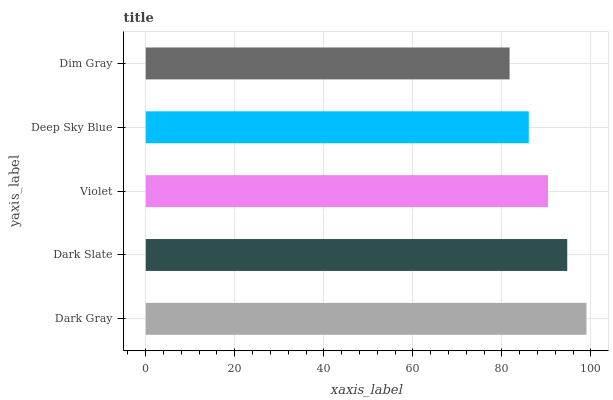Is Dim Gray the minimum?
Answer yes or no. Yes. Is Dark Gray the maximum?
Answer yes or no. Yes. Is Dark Slate the minimum?
Answer yes or no. No. Is Dark Slate the maximum?
Answer yes or no. No. Is Dark Gray greater than Dark Slate?
Answer yes or no. Yes. Is Dark Slate less than Dark Gray?
Answer yes or no. Yes. Is Dark Slate greater than Dark Gray?
Answer yes or no. No. Is Dark Gray less than Dark Slate?
Answer yes or no. No. Is Violet the high median?
Answer yes or no. Yes. Is Violet the low median?
Answer yes or no. Yes. Is Dark Gray the high median?
Answer yes or no. No. Is Dim Gray the low median?
Answer yes or no. No. 